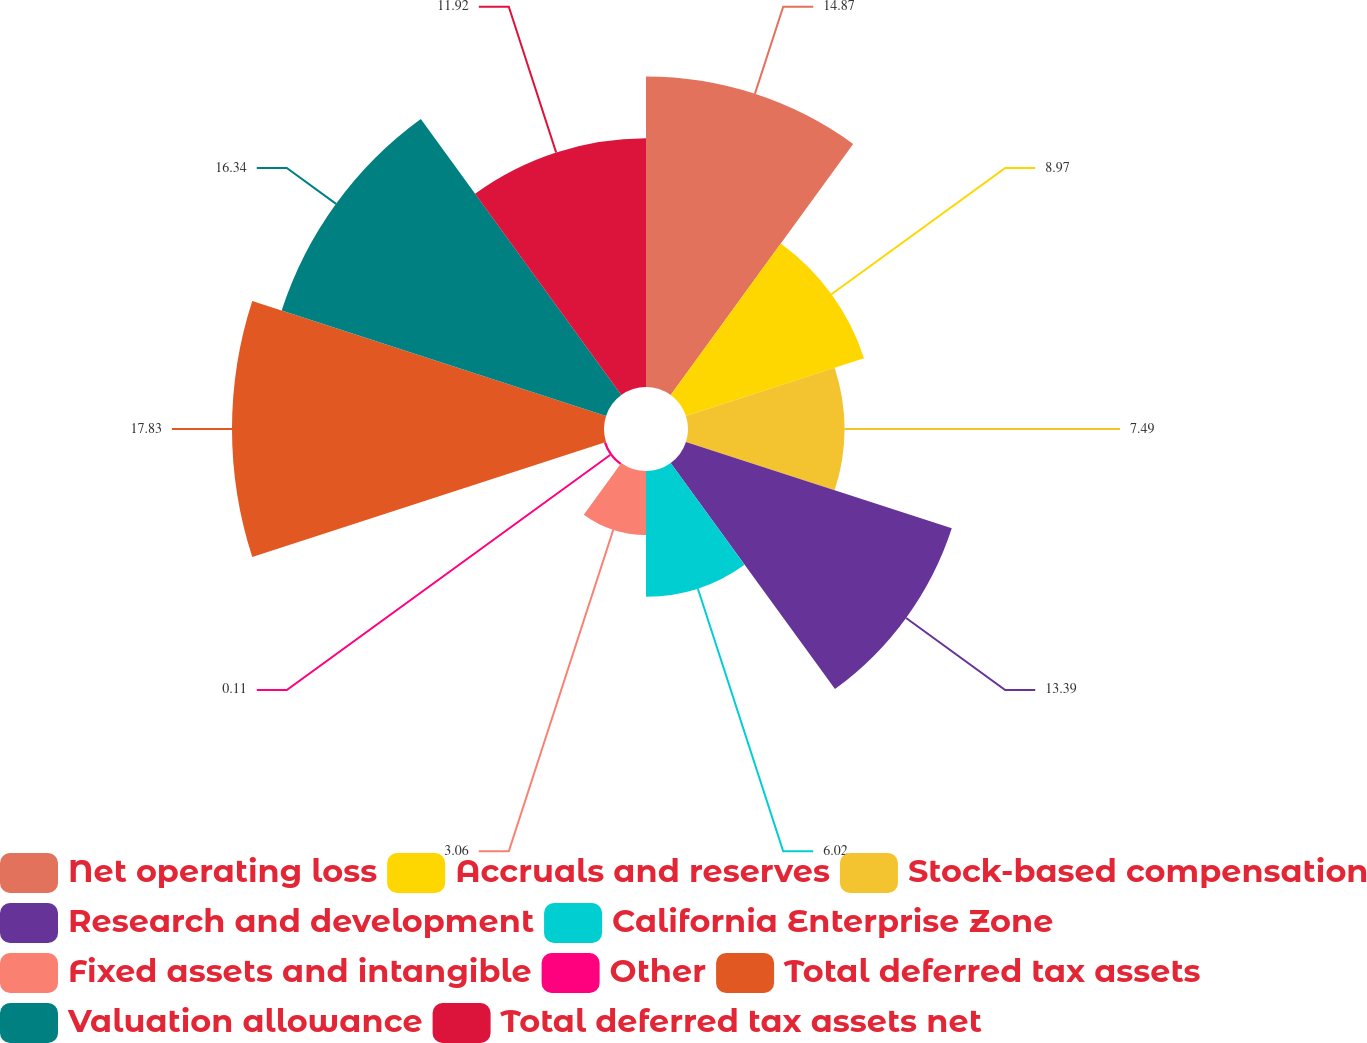Convert chart to OTSL. <chart><loc_0><loc_0><loc_500><loc_500><pie_chart><fcel>Net operating loss<fcel>Accruals and reserves<fcel>Stock-based compensation<fcel>Research and development<fcel>California Enterprise Zone<fcel>Fixed assets and intangible<fcel>Other<fcel>Total deferred tax assets<fcel>Valuation allowance<fcel>Total deferred tax assets net<nl><fcel>14.87%<fcel>8.97%<fcel>7.49%<fcel>13.39%<fcel>6.02%<fcel>3.06%<fcel>0.11%<fcel>17.82%<fcel>16.34%<fcel>11.92%<nl></chart> 